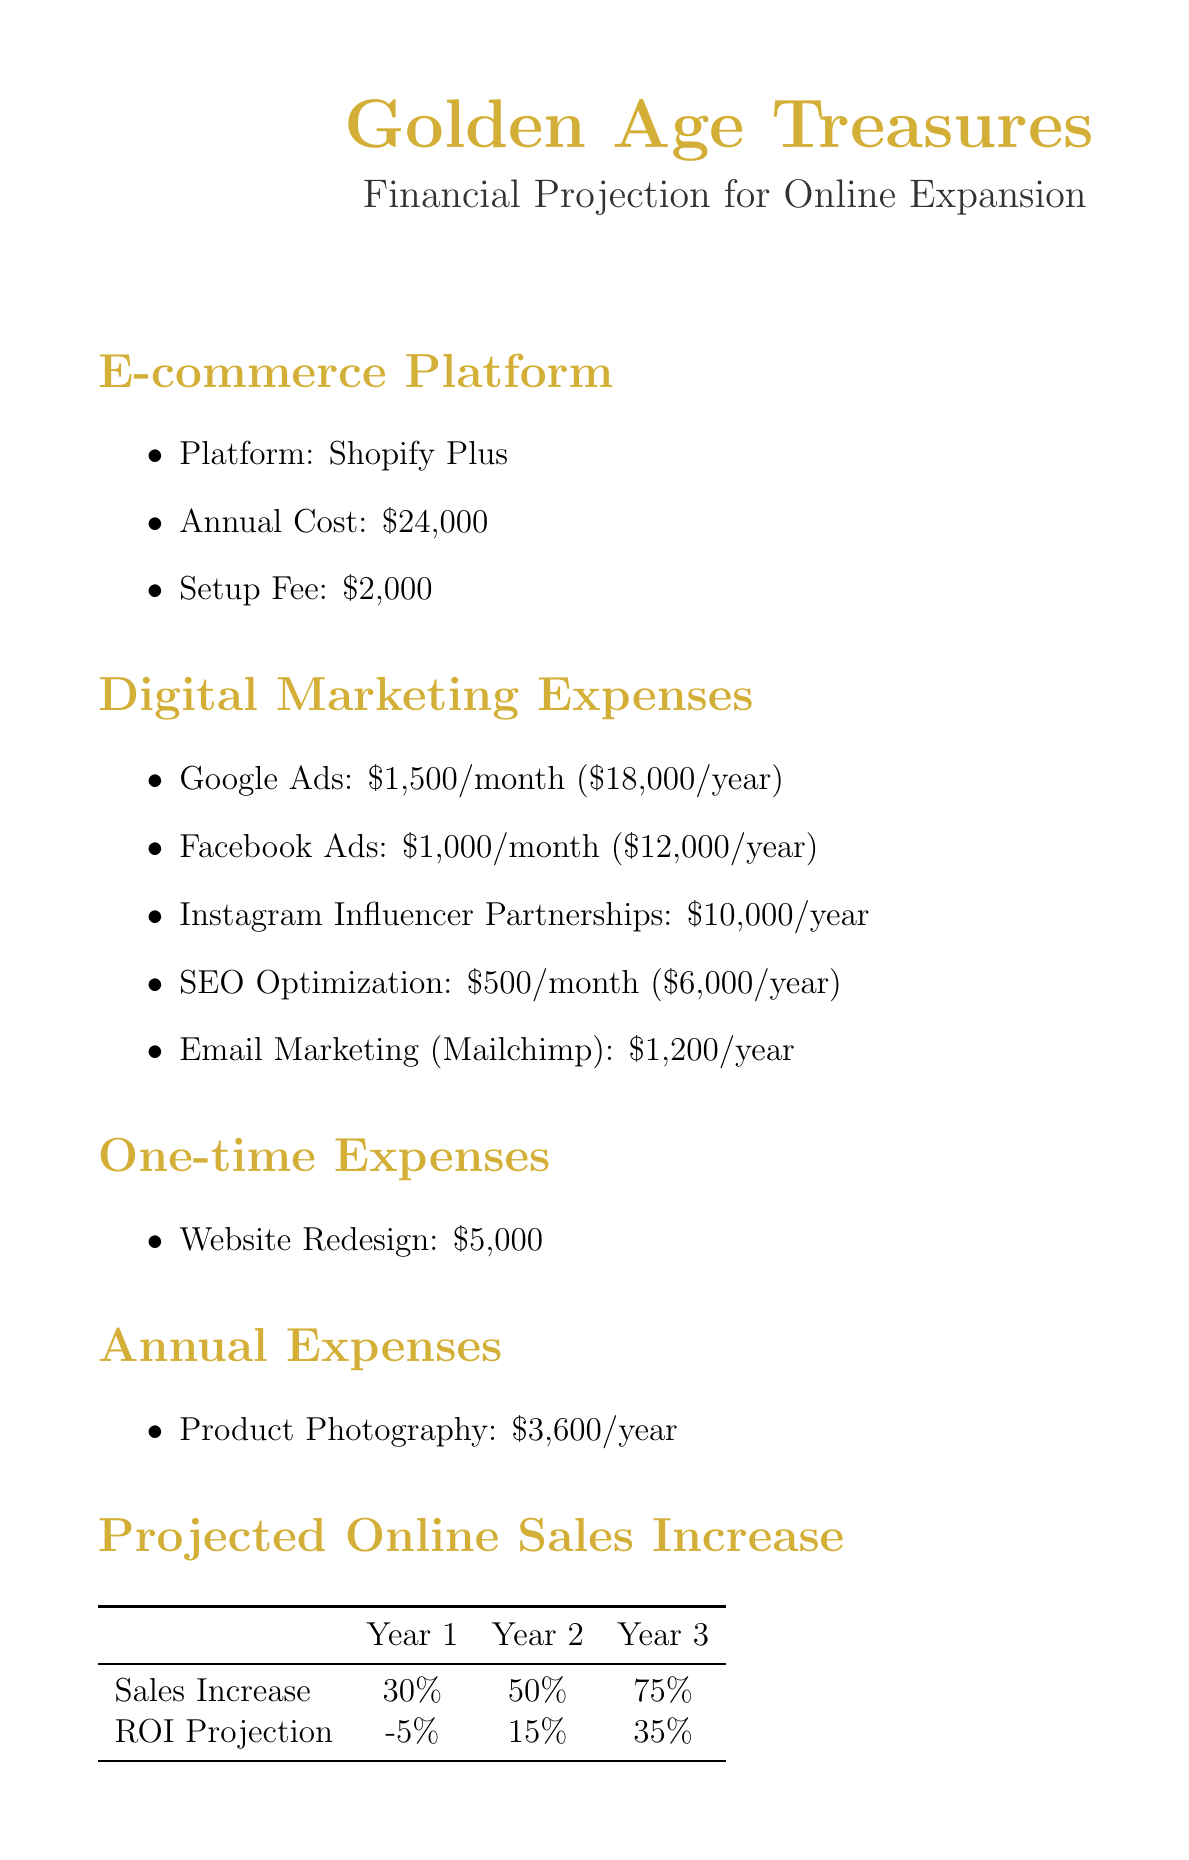What is the annual cost of the e-commerce platform? The annual cost of the e-commerce platform, Shopify Plus, is specified as $24,000.
Answer: $24,000 What is the setup fee for the e-commerce platform? The setup fee for the Shopify Plus e-commerce platform is mentioned as $2,000.
Answer: $2,000 What is the annual budget for Instagram influencer partnerships? The annual budget dedicated to Instagram influencer partnerships is clearly stated as $10,000.
Answer: $10,000 What is the total annual cost for digital marketing expenses? The total annual cost can be calculated by summing all individual digital marketing expenses: $18,000 (Google Ads) + $12,000 (Facebook Ads) + $10,000 (Instagram) + $6,000 (SEO) + $1,200 (Email Marketing) = $47,200.
Answer: $47,200 What is the projected online sales increase in year 2? The document states that the projected online sales increase for year 2 is 50%.
Answer: 50% What is the ROI projection for year 1? The document states the ROI projection for year 1 is -5%.
Answer: -5% What is the one-time cost associated with website redesign? The document specifies that the one-time cost for website redesign is $5,000.
Answer: $5,000 Which email marketing software is mentioned? The email marketing software mentioned in the document is Mailchimp.
Answer: Mailchimp How many key performance indicators are listed? The document lists four key performance indicators.
Answer: 4 